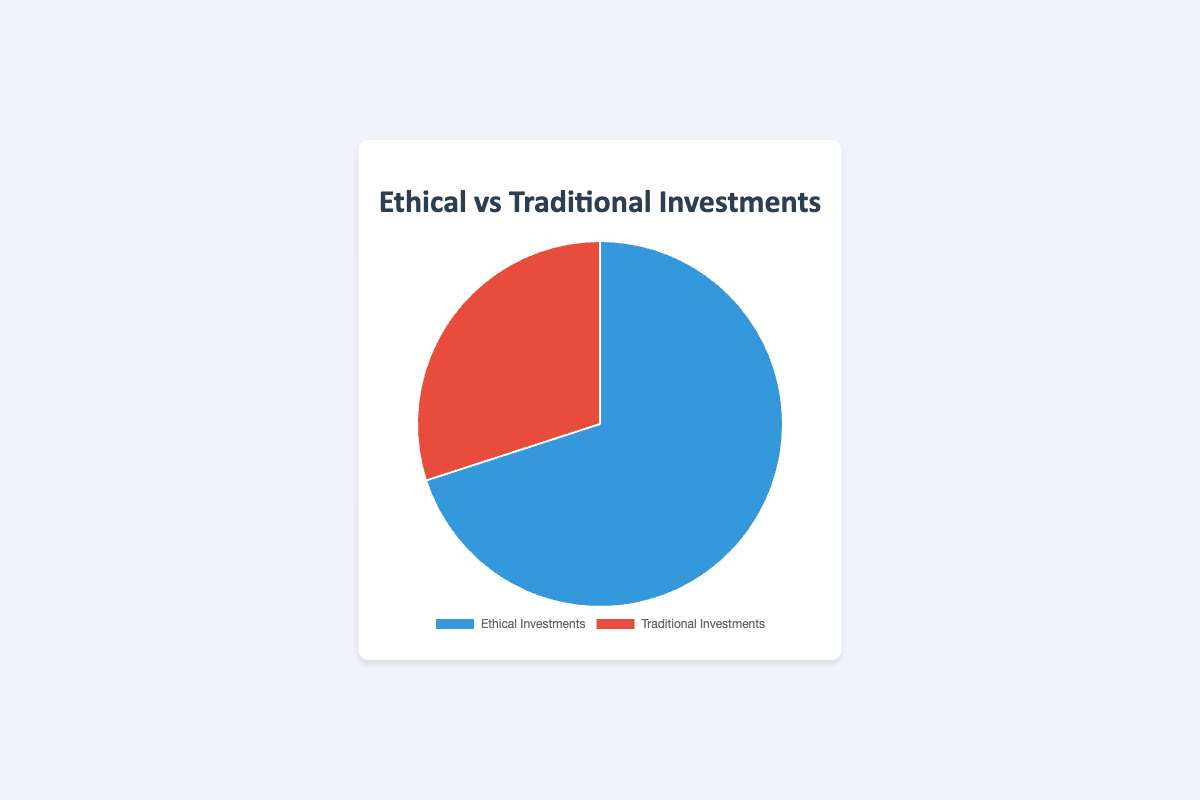What percentage of the total investments are ethical investments? To find the percentage of total investments that are ethical, refer to the segment of the pie chart labeled "Ethical Investments". This segment is 70% of the total investments.
Answer: 70% Which type of investments has a smaller percentage in the pie chart? Compare the percentages of the two types of investments shown in the pie chart. The "Traditional Investments" segment has a smaller percentage (30%) compared to the "Ethical Investments" segment (70%).
Answer: Traditional Investments By how much do ethical investments exceed traditional investments? Calculate the difference between the percentages of ethical and traditional investments: 70% (ethical) - 30% (traditional) = 40%.
Answer: 40% If we combine the percentages of traditional investments from Fidelity and Vanguard, what is the total? Add the percentages for Fidelity (20%) and Vanguard (15%) in the traditional investments category: 20% + 15% = 35%.
Answer: 35% What is the combined percentage of Calvert Investment Management and Pax World Funds in the ethical investments category? Combine the percentages of Calvert Investment Management (25%) and Pax World Funds (20%): 25% + 20% = 45%.
Answer: 45% Which color represents traditional investments in the pie chart? Refer to the visual attributes of the pie chart. Traditional investments are represented by the red segment.
Answer: Red What percentage of the pie chart is dedicated to Calvert Investment Management? Calvert Investment Management is part of the ethical investments category, which overall is 70%. Its specific share within ethical investments is 25% of 70%, so it's 25%.
Answer: 25% How do the percentages of T. Rowe Price and Schwab add up in traditional investments? Combine the percentages for T. Rowe Price (10%) and Schwab (5%) within traditional investments: 10% + 5% = 15%.
Answer: 15% If Parnassus Investments were to decrease its percentage by 5%, what would the new percentage for ethical investments be? Currently, Parnassus Investments holds 10% of ethical investments. Subtracting 5% would make it 5%. Since ethical investments total 70%, 70% - 5% = 65%. However, the entire pie chart remains unchanged (70% ethical, 30% traditional).
Answer: 70% 